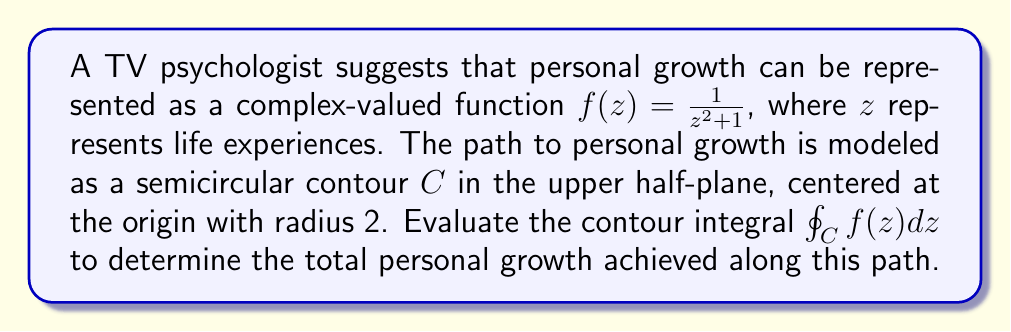Show me your answer to this math problem. To evaluate this contour integral, we'll use the Residue Theorem. Let's follow these steps:

1) First, we need to find the poles of $f(z)$ inside the contour $C$. The poles are the roots of $z^2 + 1 = 0$:
   
   $z = \pm i$

   Only $z = i$ lies inside the contour (upper half-plane).

2) The residue at $z = i$ can be calculated as follows:
   
   $\text{Res}(f, i) = \lim_{z \to i} (z-i)f(z) = \lim_{z \to i} \frac{z-i}{z^2+1} = \frac{1}{2i}$

3) The Residue Theorem states that for a closed contour $C$:
   
   $\oint_C f(z) dz = 2\pi i \sum \text{Res}(f, a_k)$

   where $a_k$ are the poles of $f(z)$ inside $C$.

4) In our case, we have a semicircular contour, so we need to multiply the result by $\frac{1}{2}$:
   
   $\oint_C f(z) dz = \frac{1}{2} \cdot 2\pi i \cdot \text{Res}(f, i) = \frac{1}{2} \cdot 2\pi i \cdot \frac{1}{2i} = \frac{\pi}{2}$

This result represents the total personal growth achieved along the given path of life experiences.

[asy]
import graph;
size(200);
draw(Circle((0,0),2),blue);
draw((-2,0)--(2,0),blue);
dot((0,1),red);
label("$i$",(0,1),NE);
label("$C$",(1.5,1.5),NE);
[/asy]
Answer: $\frac{\pi}{2}$ 